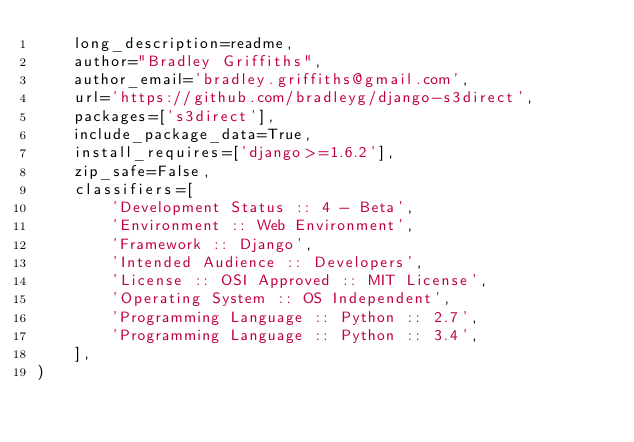<code> <loc_0><loc_0><loc_500><loc_500><_Python_>    long_description=readme,
    author="Bradley Griffiths",
    author_email='bradley.griffiths@gmail.com',
    url='https://github.com/bradleyg/django-s3direct',
    packages=['s3direct'],
    include_package_data=True,
    install_requires=['django>=1.6.2'],
    zip_safe=False,
    classifiers=[
        'Development Status :: 4 - Beta',
        'Environment :: Web Environment',
        'Framework :: Django',
        'Intended Audience :: Developers',
        'License :: OSI Approved :: MIT License',
        'Operating System :: OS Independent',
        'Programming Language :: Python :: 2.7',
        'Programming Language :: Python :: 3.4',
    ],
)
</code> 